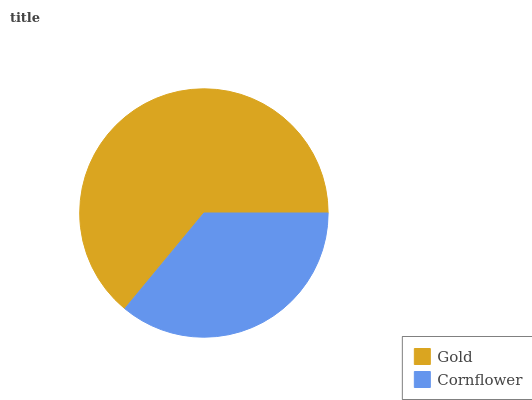Is Cornflower the minimum?
Answer yes or no. Yes. Is Gold the maximum?
Answer yes or no. Yes. Is Cornflower the maximum?
Answer yes or no. No. Is Gold greater than Cornflower?
Answer yes or no. Yes. Is Cornflower less than Gold?
Answer yes or no. Yes. Is Cornflower greater than Gold?
Answer yes or no. No. Is Gold less than Cornflower?
Answer yes or no. No. Is Gold the high median?
Answer yes or no. Yes. Is Cornflower the low median?
Answer yes or no. Yes. Is Cornflower the high median?
Answer yes or no. No. Is Gold the low median?
Answer yes or no. No. 